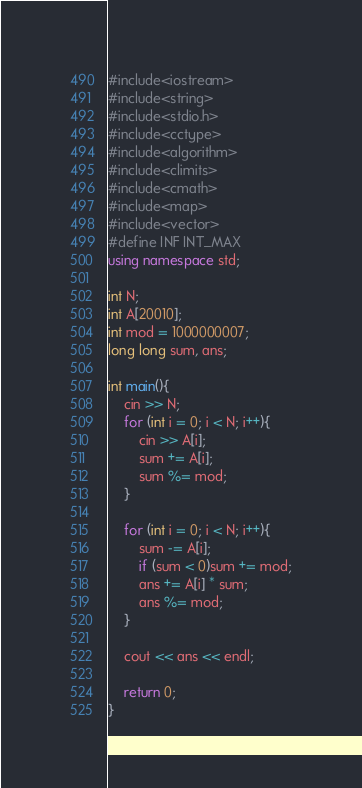Convert code to text. <code><loc_0><loc_0><loc_500><loc_500><_C++_>#include<iostream>
#include<string>
#include<stdio.h>
#include<cctype>
#include<algorithm>
#include<climits>
#include<cmath>
#include<map>
#include<vector>
#define INF INT_MAX
using namespace std;

int N;
int A[20010];
int mod = 1000000007;
long long sum, ans;

int main(){
	cin >> N;
	for (int i = 0; i < N; i++){
		cin >> A[i];
		sum += A[i];
		sum %= mod;
	}
	
	for (int i = 0; i < N; i++){
		sum -= A[i];
		if (sum < 0)sum += mod;
		ans += A[i] * sum;
		ans %= mod;
	}

	cout << ans << endl;

	return 0;
}</code> 